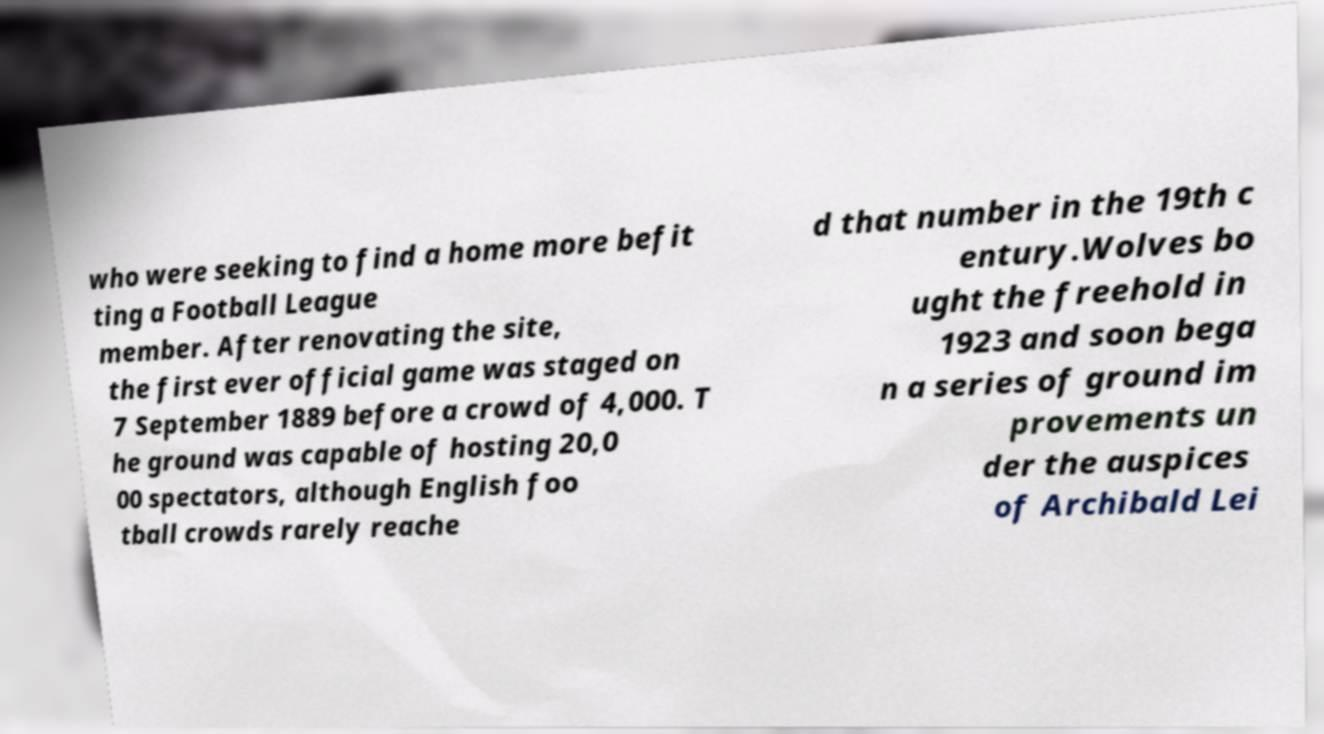Can you read and provide the text displayed in the image?This photo seems to have some interesting text. Can you extract and type it out for me? who were seeking to find a home more befit ting a Football League member. After renovating the site, the first ever official game was staged on 7 September 1889 before a crowd of 4,000. T he ground was capable of hosting 20,0 00 spectators, although English foo tball crowds rarely reache d that number in the 19th c entury.Wolves bo ught the freehold in 1923 and soon bega n a series of ground im provements un der the auspices of Archibald Lei 